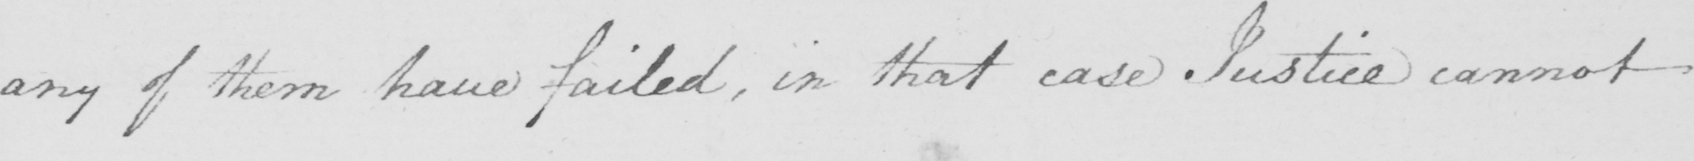Transcribe the text shown in this historical manuscript line. any of them have failed, in that case Justice cannot 